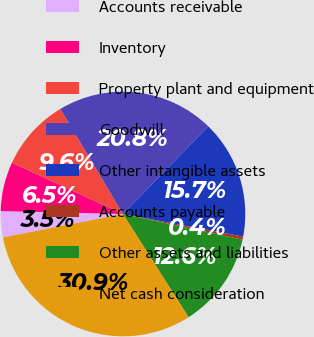Convert chart to OTSL. <chart><loc_0><loc_0><loc_500><loc_500><pie_chart><fcel>Accounts receivable<fcel>Inventory<fcel>Property plant and equipment<fcel>Goodwill<fcel>Other intangible assets<fcel>Accounts payable<fcel>Other assets and liabilities<fcel>Net cash consideration<nl><fcel>3.45%<fcel>6.51%<fcel>9.56%<fcel>20.84%<fcel>15.67%<fcel>0.4%<fcel>12.62%<fcel>30.94%<nl></chart> 